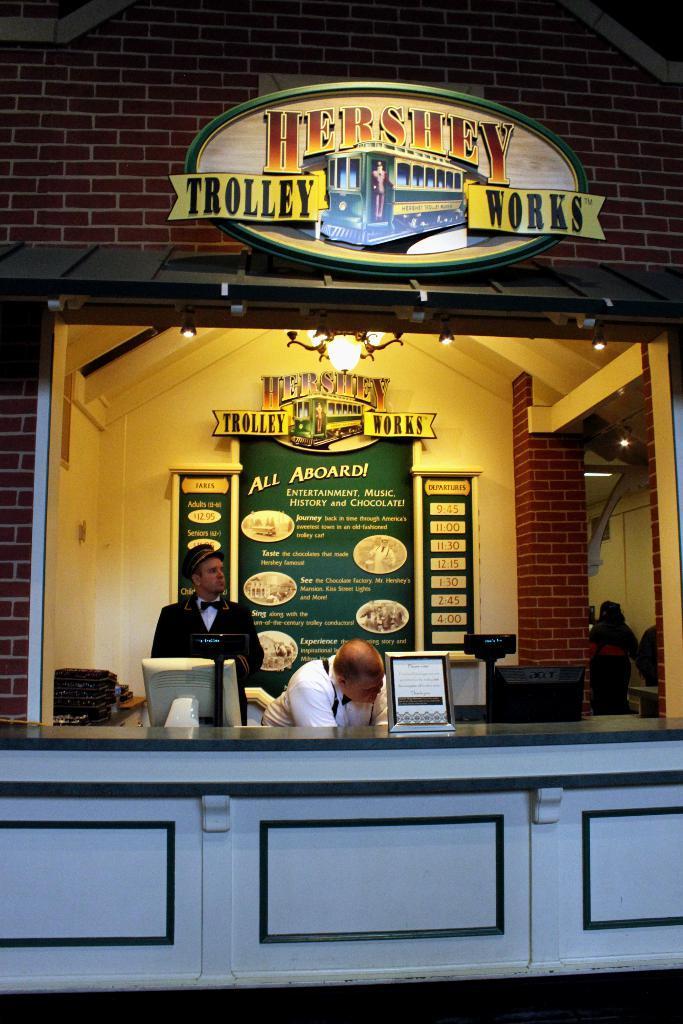How would you summarize this image in a sentence or two? In this image, we can see a brick building. There is a table with an object on it. There are few people. In the background, we can see a poster with some images and text printed on it. 